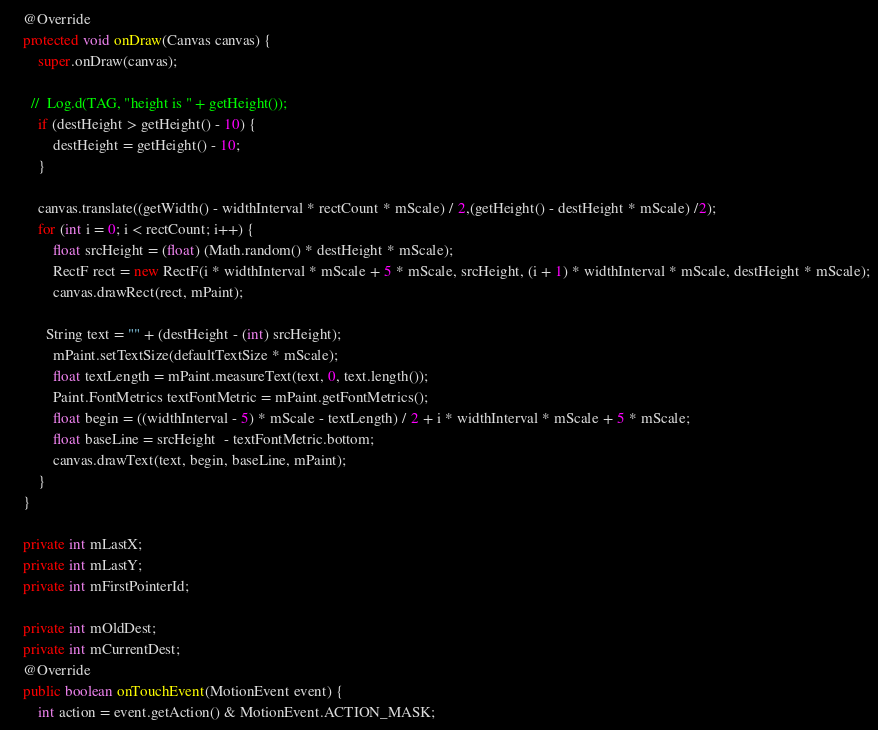<code> <loc_0><loc_0><loc_500><loc_500><_Java_>    @Override
    protected void onDraw(Canvas canvas) {
        super.onDraw(canvas);

      //  Log.d(TAG, "height is " + getHeight());
        if (destHeight > getHeight() - 10) {
            destHeight = getHeight() - 10;
        }

        canvas.translate((getWidth() - widthInterval * rectCount * mScale) / 2,(getHeight() - destHeight * mScale) /2);
        for (int i = 0; i < rectCount; i++) {
            float srcHeight = (float) (Math.random() * destHeight * mScale);
            RectF rect = new RectF(i * widthInterval * mScale + 5 * mScale, srcHeight, (i + 1) * widthInterval * mScale, destHeight * mScale);
            canvas.drawRect(rect, mPaint);

          String text = "" + (destHeight - (int) srcHeight);
            mPaint.setTextSize(defaultTextSize * mScale);
            float textLength = mPaint.measureText(text, 0, text.length());
            Paint.FontMetrics textFontMetric = mPaint.getFontMetrics();
            float begin = ((widthInterval - 5) * mScale - textLength) / 2 + i * widthInterval * mScale + 5 * mScale;
            float baseLine = srcHeight  - textFontMetric.bottom;
            canvas.drawText(text, begin, baseLine, mPaint);
        }
    }

    private int mLastX;
    private int mLastY;
    private int mFirstPointerId;

    private int mOldDest;
    private int mCurrentDest;
    @Override
    public boolean onTouchEvent(MotionEvent event) {
        int action = event.getAction() & MotionEvent.ACTION_MASK;
</code> 